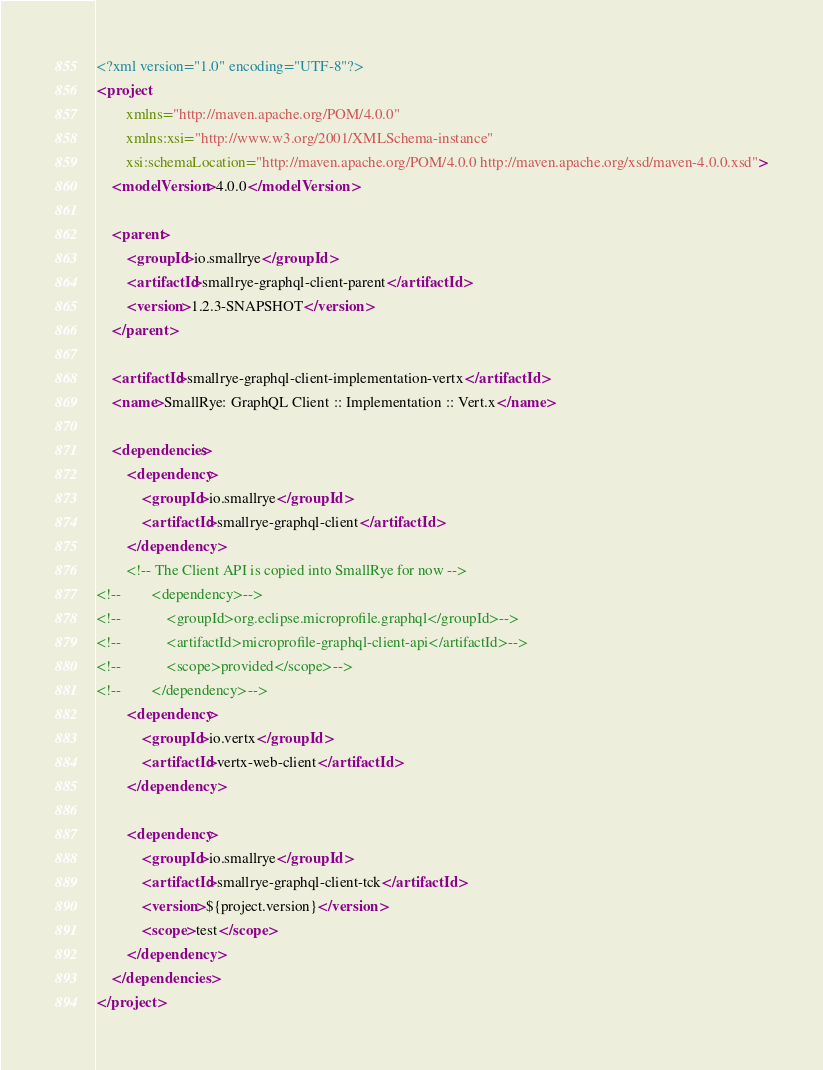<code> <loc_0><loc_0><loc_500><loc_500><_XML_><?xml version="1.0" encoding="UTF-8"?>
<project
        xmlns="http://maven.apache.org/POM/4.0.0"
        xmlns:xsi="http://www.w3.org/2001/XMLSchema-instance"
        xsi:schemaLocation="http://maven.apache.org/POM/4.0.0 http://maven.apache.org/xsd/maven-4.0.0.xsd">
    <modelVersion>4.0.0</modelVersion>

    <parent>
        <groupId>io.smallrye</groupId>
        <artifactId>smallrye-graphql-client-parent</artifactId>
        <version>1.2.3-SNAPSHOT</version>
    </parent>

    <artifactId>smallrye-graphql-client-implementation-vertx</artifactId>
    <name>SmallRye: GraphQL Client :: Implementation :: Vert.x</name>

    <dependencies>
        <dependency>
            <groupId>io.smallrye</groupId>
            <artifactId>smallrye-graphql-client</artifactId>
        </dependency>
        <!-- The Client API is copied into SmallRye for now -->
<!--        <dependency>-->
<!--            <groupId>org.eclipse.microprofile.graphql</groupId>-->
<!--            <artifactId>microprofile-graphql-client-api</artifactId>-->
<!--            <scope>provided</scope>-->
<!--        </dependency>-->
        <dependency>
            <groupId>io.vertx</groupId>
            <artifactId>vertx-web-client</artifactId>
        </dependency>

        <dependency>
            <groupId>io.smallrye</groupId>
            <artifactId>smallrye-graphql-client-tck</artifactId>
            <version>${project.version}</version>
            <scope>test</scope>
        </dependency>
    </dependencies>
</project>
</code> 